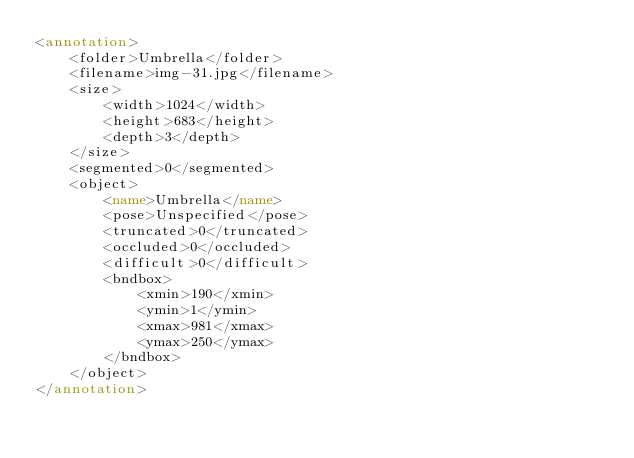Convert code to text. <code><loc_0><loc_0><loc_500><loc_500><_XML_><annotation>
    <folder>Umbrella</folder>
    <filename>img-31.jpg</filename>
    <size>
        <width>1024</width>
        <height>683</height>
        <depth>3</depth>
    </size>
    <segmented>0</segmented>
    <object>
        <name>Umbrella</name>
        <pose>Unspecified</pose>
        <truncated>0</truncated>
        <occluded>0</occluded>
        <difficult>0</difficult>
        <bndbox>
            <xmin>190</xmin>
            <ymin>1</ymin>
            <xmax>981</xmax>
            <ymax>250</ymax>
        </bndbox>
    </object>
</annotation></code> 